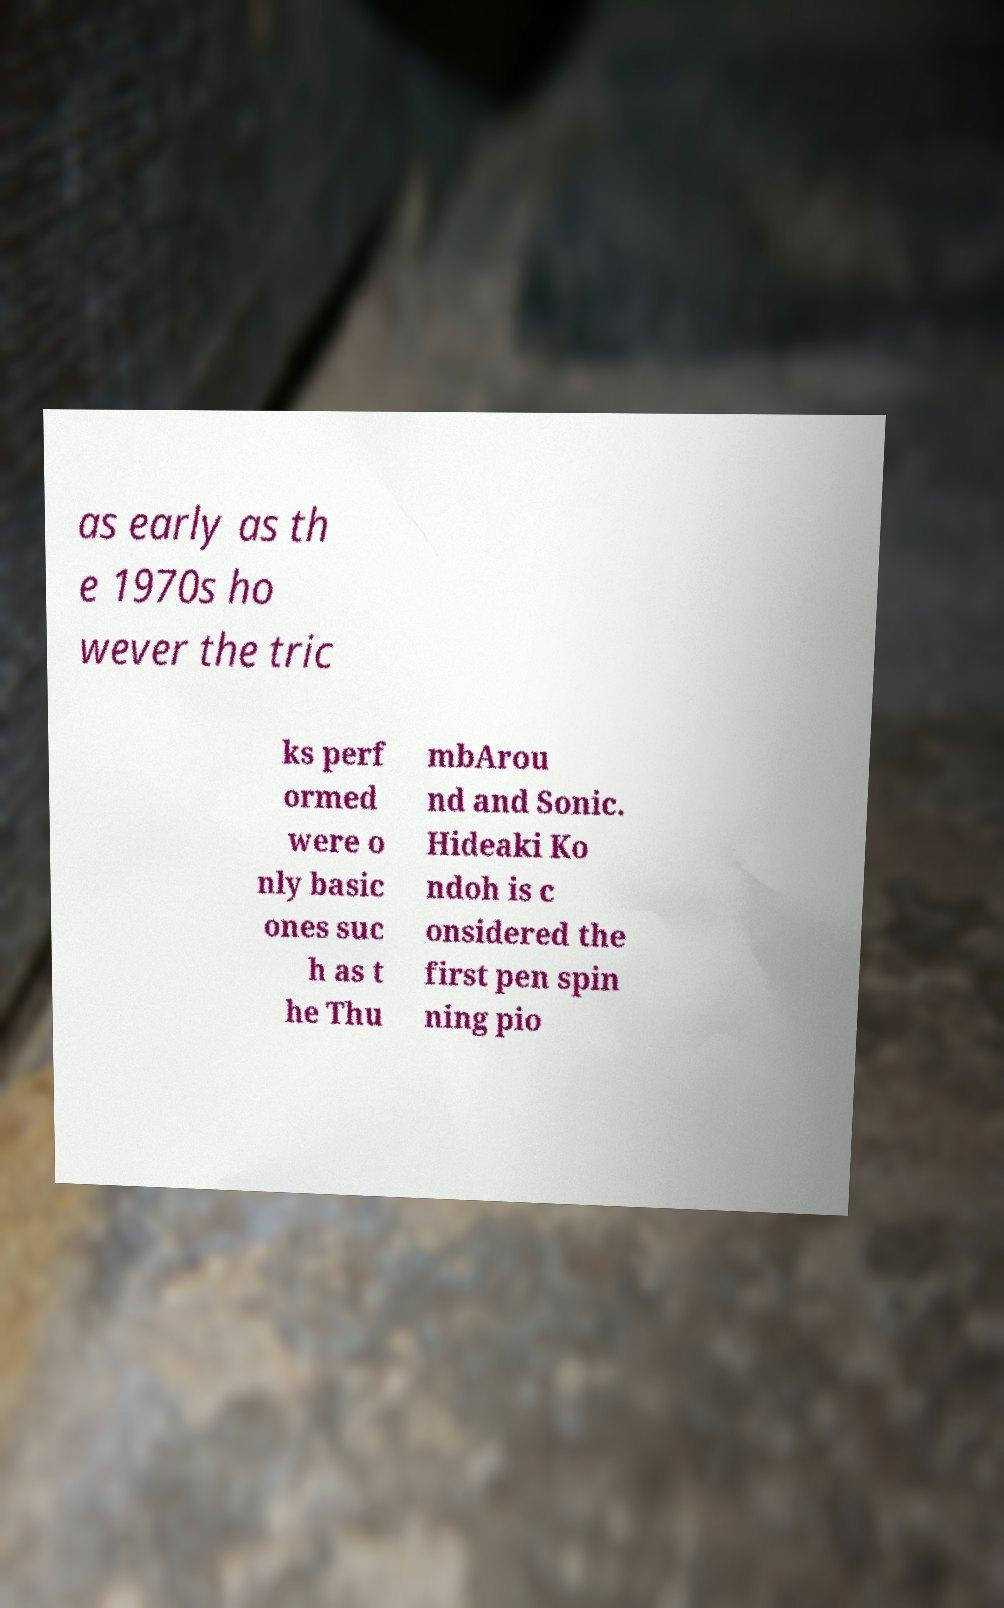Can you accurately transcribe the text from the provided image for me? as early as th e 1970s ho wever the tric ks perf ormed were o nly basic ones suc h as t he Thu mbArou nd and Sonic. Hideaki Ko ndoh is c onsidered the first pen spin ning pio 